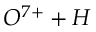Convert formula to latex. <formula><loc_0><loc_0><loc_500><loc_500>O ^ { 7 + } + H</formula> 